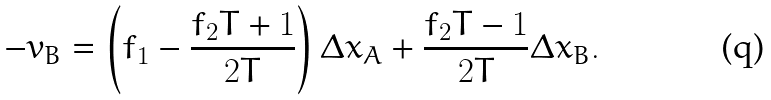<formula> <loc_0><loc_0><loc_500><loc_500>- v _ { B } = \left ( f _ { 1 } - \frac { f _ { 2 } T + 1 } { 2 T } \right ) \Delta x _ { A } + \frac { f _ { 2 } T - 1 } { 2 T } \Delta x _ { B } .</formula> 